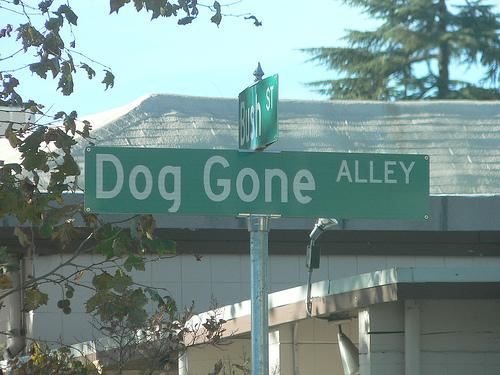Question: what does the sign say?
Choices:
A. Stop.
B. Dog Gone Alley.
C. No pets allowed.
D. One way.
Answer with the letter. Answer: B Question: what does the other street sign say?
Choices:
A. Walnut Dr.
B. Dead End.
C. Bush St.
D. Rodeo Dr.
Answer with the letter. Answer: C Question: where was this taken?
Choices:
A. Inside a school.
B. Outside in a neighborhood.
C. In a park.
D. In a gym.
Answer with the letter. Answer: B Question: what color are the street signs?
Choices:
A. Green.
B. Red.
C. Yellow.
D. White.
Answer with the letter. Answer: A Question: where are the tree branches?
Choices:
A. Left of the signs.
B. Right of the signs.
C. Under the signs.
D. On top of the sign.
Answer with the letter. Answer: A Question: how many streets are represented?
Choices:
A. Two.
B. Three.
C. Four.
D. Five.
Answer with the letter. Answer: A Question: when was this taken?
Choices:
A. Night.
B. During the day.
C. Dusk.
D. Morning.
Answer with the letter. Answer: B 